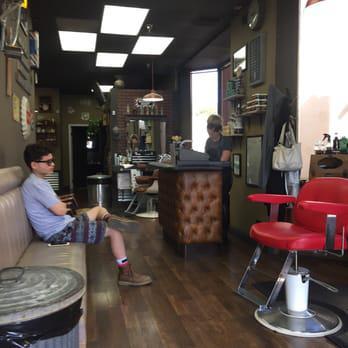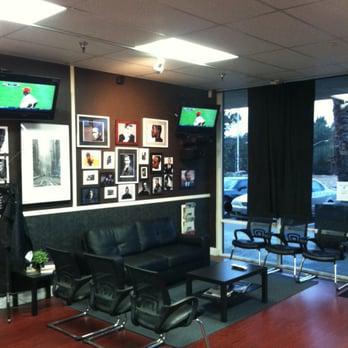The first image is the image on the left, the second image is the image on the right. Examine the images to the left and right. Is the description "There is no more than two flat screen televisions in the right image." accurate? Answer yes or no. Yes. The first image is the image on the left, the second image is the image on the right. Analyze the images presented: Is the assertion "In one of the image there is at least one man sitting down on a couch." valid? Answer yes or no. Yes. 